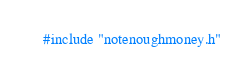<code> <loc_0><loc_0><loc_500><loc_500><_C++_>#include "notenoughmoney.h"

</code> 